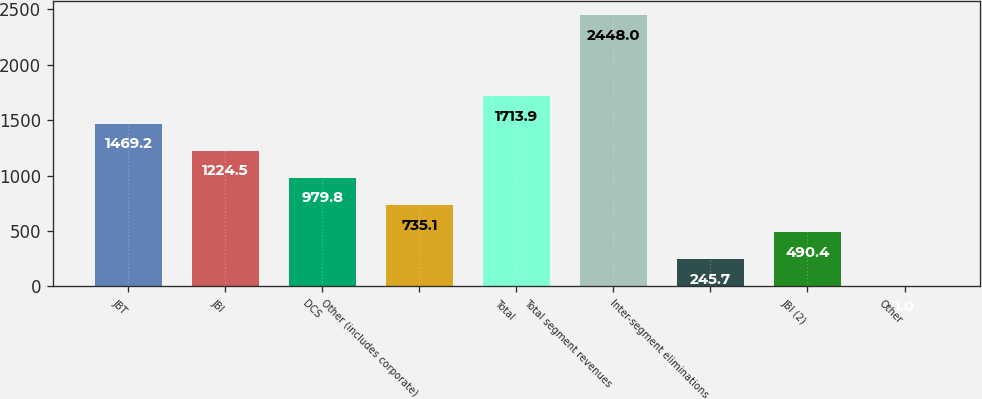Convert chart to OTSL. <chart><loc_0><loc_0><loc_500><loc_500><bar_chart><fcel>JBT<fcel>JBI<fcel>DCS<fcel>Other (includes corporate)<fcel>Total<fcel>Total segment revenues<fcel>Inter-segment eliminations<fcel>JBI (2)<fcel>Other<nl><fcel>1469.2<fcel>1224.5<fcel>979.8<fcel>735.1<fcel>1713.9<fcel>2448<fcel>245.7<fcel>490.4<fcel>1<nl></chart> 